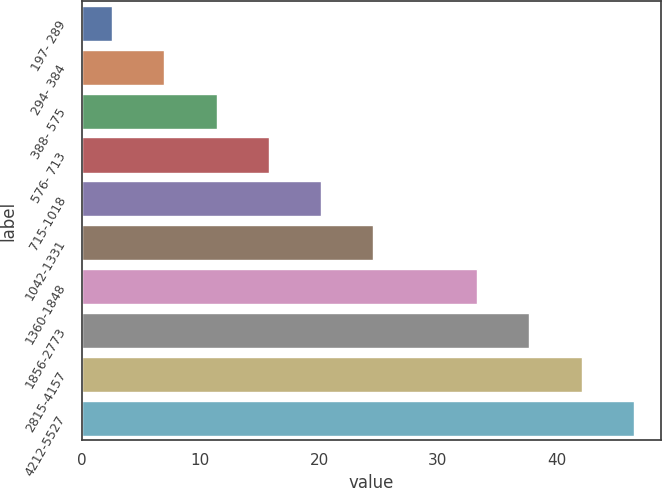Convert chart. <chart><loc_0><loc_0><loc_500><loc_500><bar_chart><fcel>197- 289<fcel>294- 384<fcel>388- 575<fcel>576- 713<fcel>715-1018<fcel>1042-1331<fcel>1360-1848<fcel>1856-2773<fcel>2815-4157<fcel>4212-5527<nl><fcel>2.59<fcel>6.98<fcel>11.37<fcel>15.76<fcel>20.15<fcel>24.54<fcel>33.32<fcel>37.71<fcel>42.1<fcel>46.49<nl></chart> 